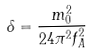Convert formula to latex. <formula><loc_0><loc_0><loc_500><loc_500>\delta = \frac { m _ { 0 } ^ { 2 } } { 2 4 \pi ^ { 2 } f _ { A } ^ { 2 } }</formula> 